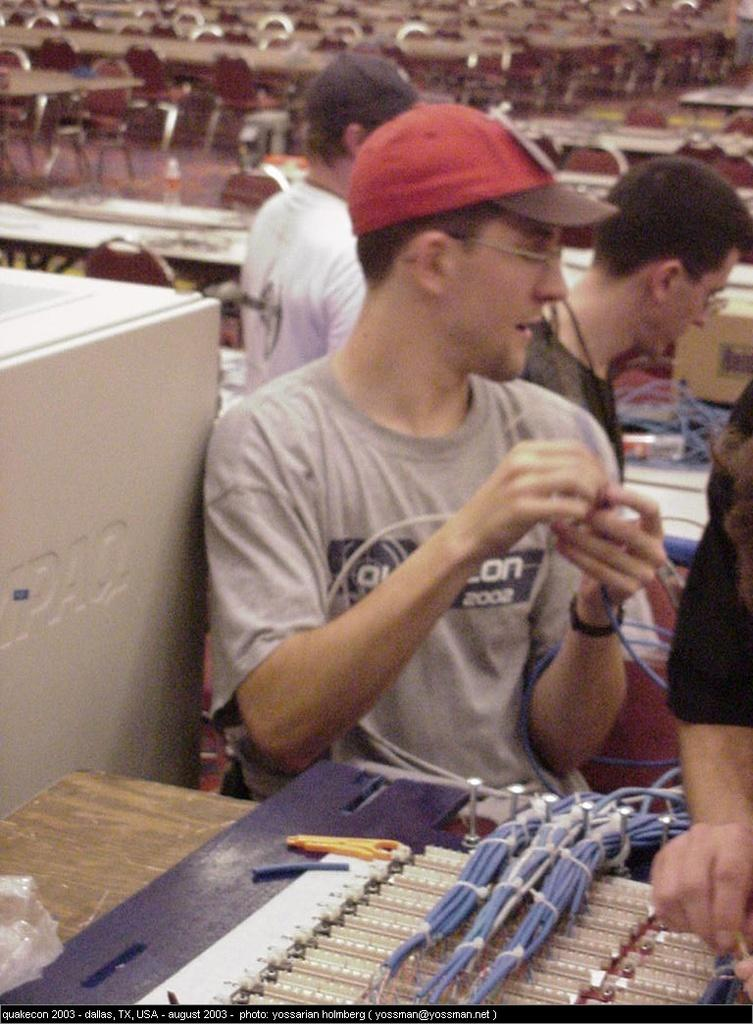What is the person in the image doing? The person is standing at a table. What can be seen on the table in the image? The table has circuits and wires on it. Can you describe the background of the image? There are other persons, tables, and a water bottle visible in the background. What type of furniture is present in the background? Chairs are present in the background. Reasoning: Let'g: Let's think step by step in order to produce the conversation. We start by identifying the main subject in the image, which is the person standing at the table. Then, we describe the table and its contents, which are circuits and wires. Next, we expand the conversation to include details about the background, such as the presence of other persons, tables, a water bottle, and chairs. Each question is designed to elicit a specific detail about the image that is known from the provided facts. Absurd Question/Answer: What type of book is the person reading at the table? There is no book present in the image; the table has circuits and wires on it. What type of meat is being prepared by the person in the image? There is no meat or cooking activity visible in the image; the person is standing at a table with circuits and wires. What type of book is the person reading at the table? There is no book present in the image; the table has circuits and wires on it. What type of meat is being prepared by the person in the image? There is no meat or cooking activity visible in the image; the person is standing at a table with circuits and wires. 